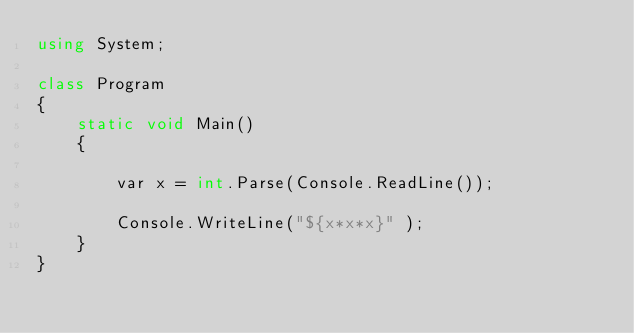<code> <loc_0><loc_0><loc_500><loc_500><_C#_>using System;

class Program
{
    static void Main()
    {
        
        var x = int.Parse(Console.ReadLine());

        Console.WriteLine("${x*x*x}" );
    }
}
</code> 